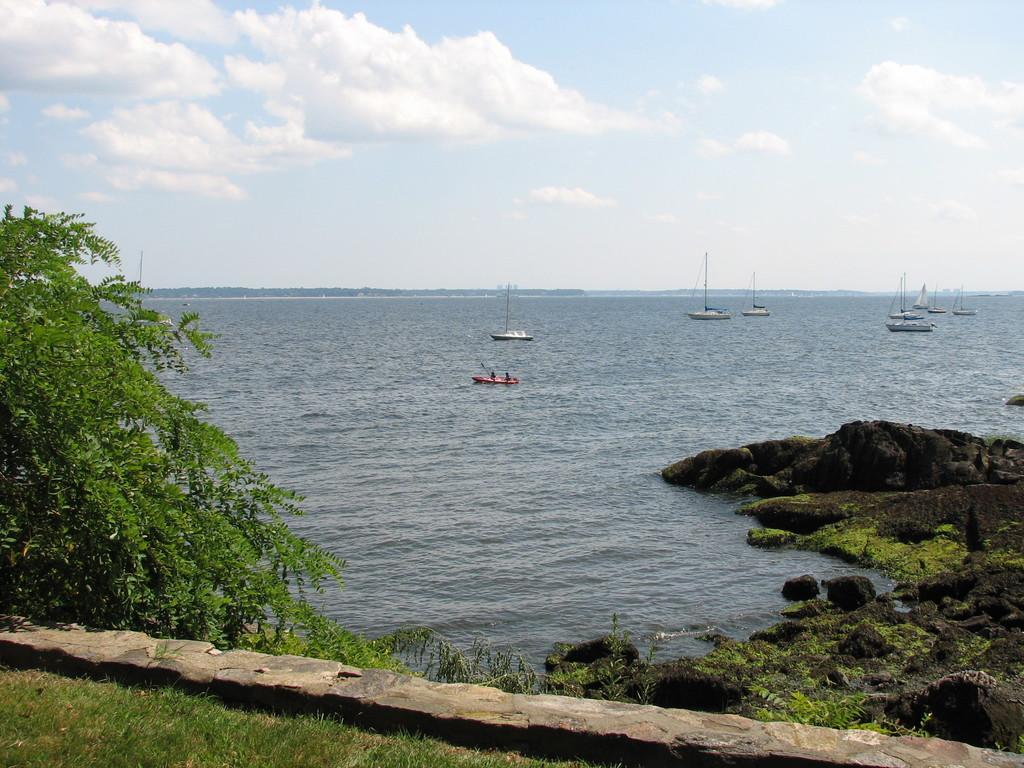Please provide a concise description of this image. In this image few boats are sailing on the water. Right side there are few rocks having grass. Left side there are trees. Bottom of image there is grassland , beside there is stone slab. Top of image there is sky with some clouds. 